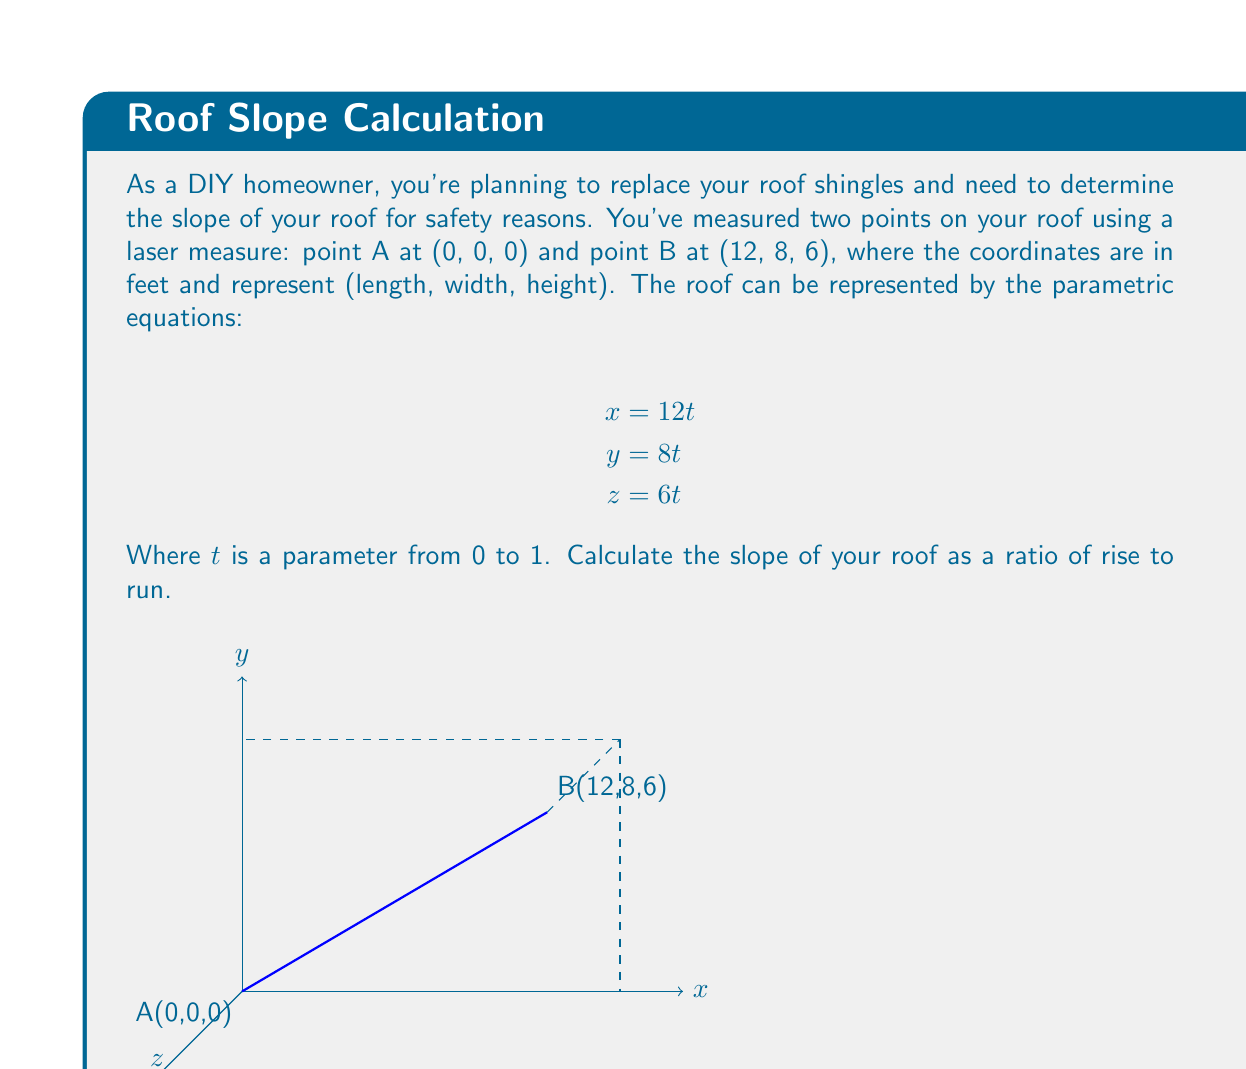Teach me how to tackle this problem. Let's approach this step-by-step:

1) The slope of a roof is typically expressed as the ratio of vertical rise to horizontal run. In this case, we need to find the rise and run between points A and B.

2) The parametric equations given represent a line from A(0,0,0) to B(12,8,6). We can use these to find the direction vector of this line:
   $\vec{v} = \langle 12, 8, 6 \rangle$

3) The vertical rise is simply the z-component of this vector: 6 feet.

4) For the run, we need to consider the horizontal distance, which is the square root of the sum of squares of x and y components:

   $$\text{run} = \sqrt{12^2 + 8^2} = \sqrt{144 + 64} = \sqrt{208} \approx 14.42 \text{ feet}$$

5) The slope is then the ratio of rise to run:

   $$\text{slope} = \frac{\text{rise}}{\text{run}} = \frac{6}{\sqrt{208}}$$

6) To express this as a ratio, we can simplify:

   $$\frac{6}{\sqrt{208}} = \frac{6}{\sqrt{16 \cdot 13}} = \frac{6}{4\sqrt{13}} = \frac{3}{2\sqrt{13}}$$

7) In roofing, slopes are often expressed as a ratio of rise over a 12-foot run. To convert our slope to this format:

   $$\frac{3}{2\sqrt{13}} \cdot \frac{12}{12} = \frac{18}{\sqrt{208}} \approx 5.03$$

This means the roof rises about 5 inches for every 12 inches of horizontal distance.
Answer: $\frac{5}{12}$ or 5:12 